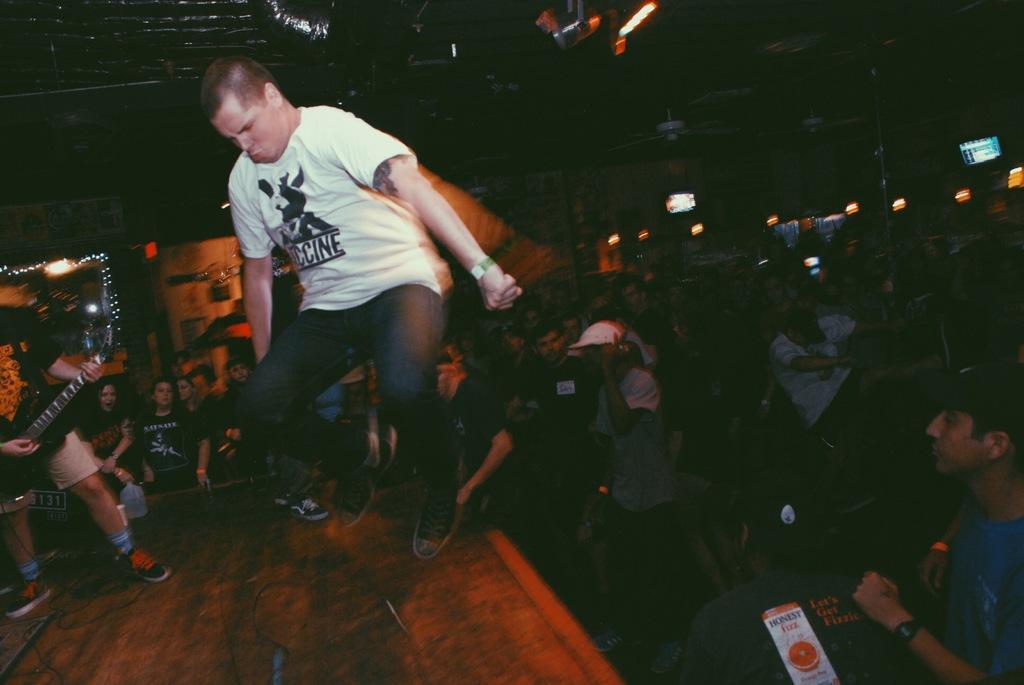In one or two sentences, can you explain what this image depicts? In this image I see a person who is holding a musical instrument and I see this man who is in the air. In the background I see lot of people and the lights. 